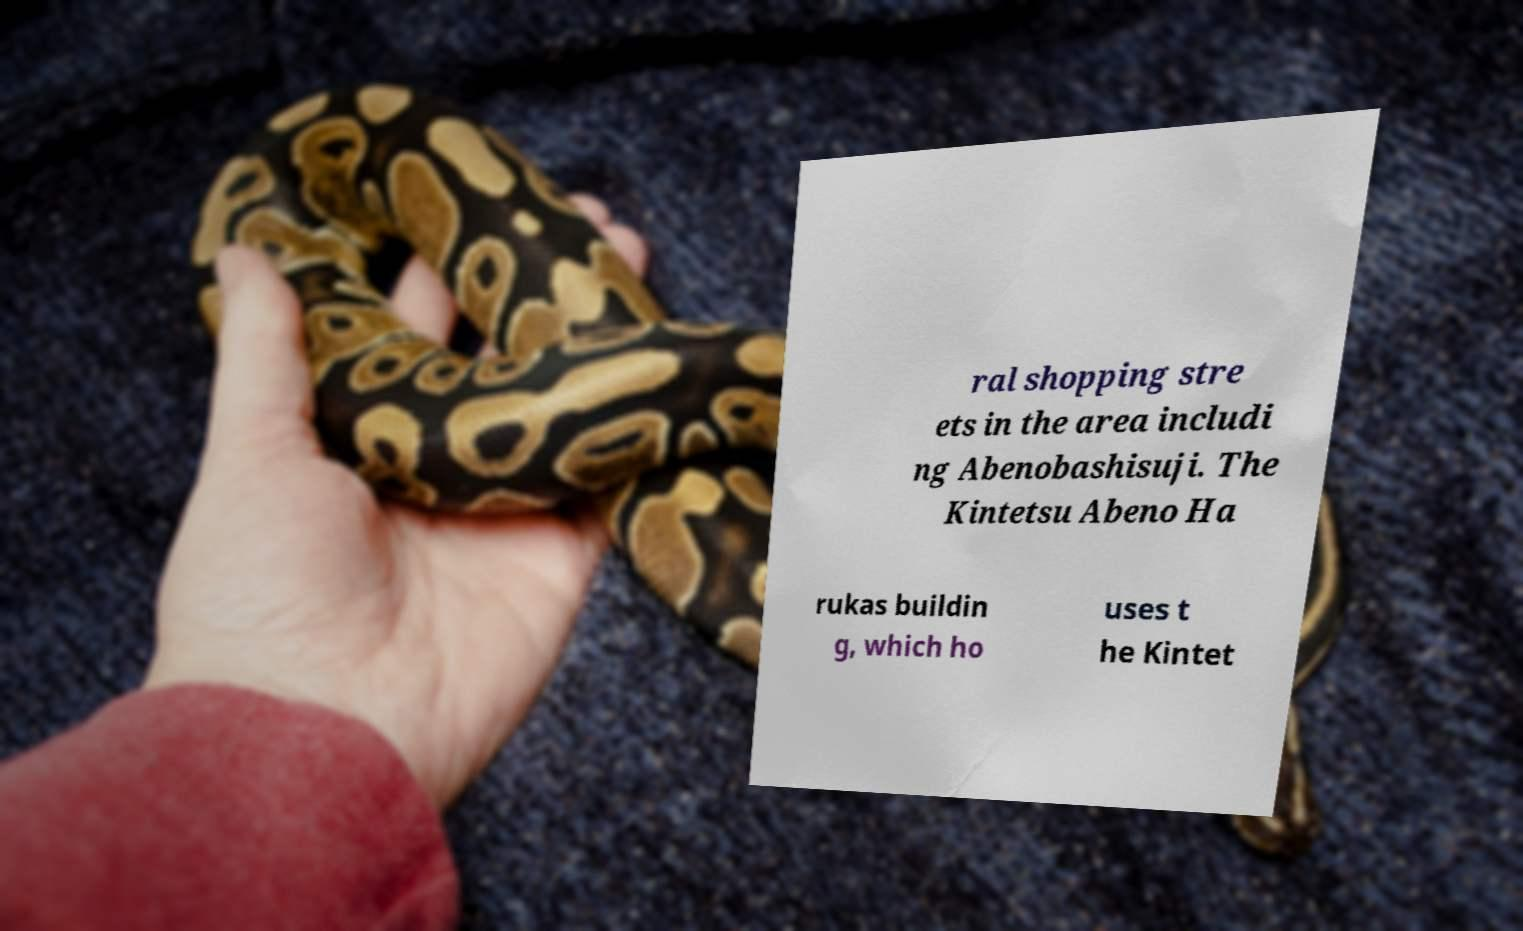Could you extract and type out the text from this image? ral shopping stre ets in the area includi ng Abenobashisuji. The Kintetsu Abeno Ha rukas buildin g, which ho uses t he Kintet 